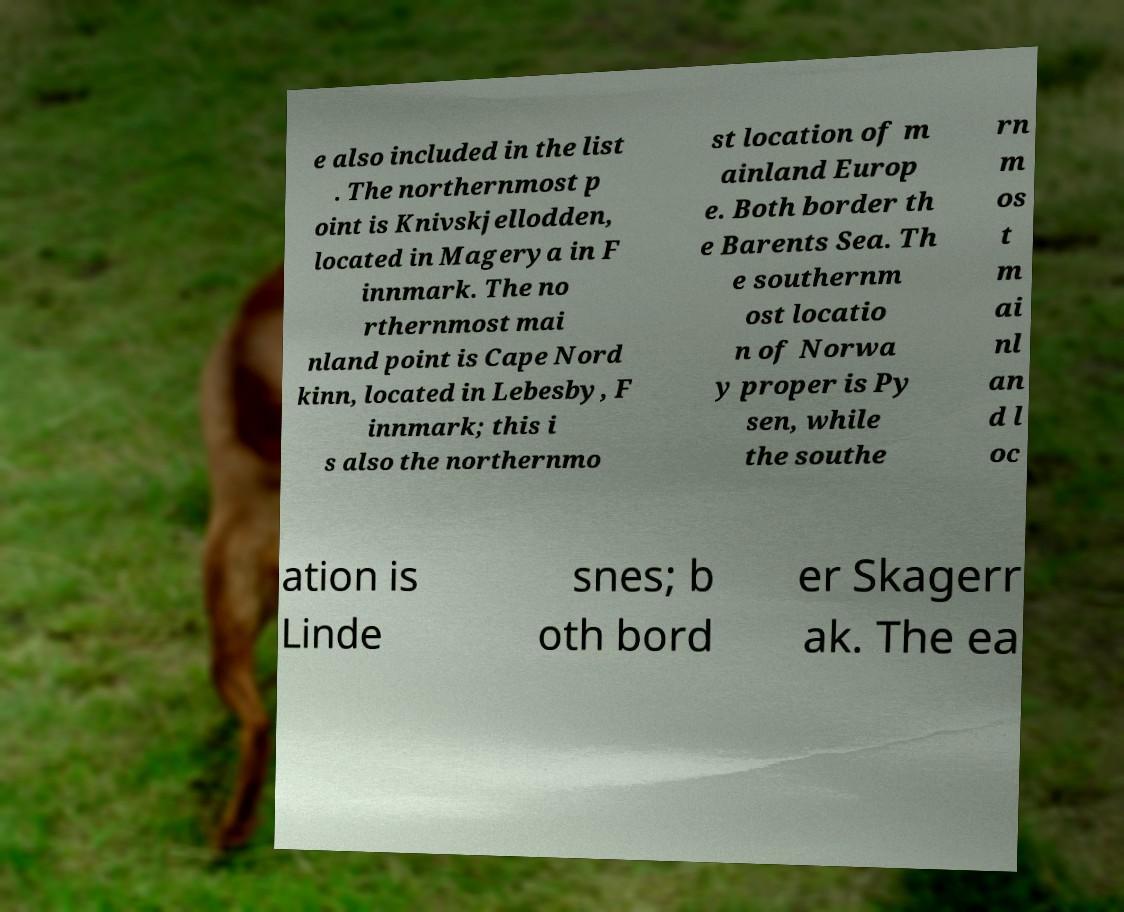Please identify and transcribe the text found in this image. e also included in the list . The northernmost p oint is Knivskjellodden, located in Magerya in F innmark. The no rthernmost mai nland point is Cape Nord kinn, located in Lebesby, F innmark; this i s also the northernmo st location of m ainland Europ e. Both border th e Barents Sea. Th e southernm ost locatio n of Norwa y proper is Py sen, while the southe rn m os t m ai nl an d l oc ation is Linde snes; b oth bord er Skagerr ak. The ea 